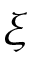<formula> <loc_0><loc_0><loc_500><loc_500>\xi</formula> 